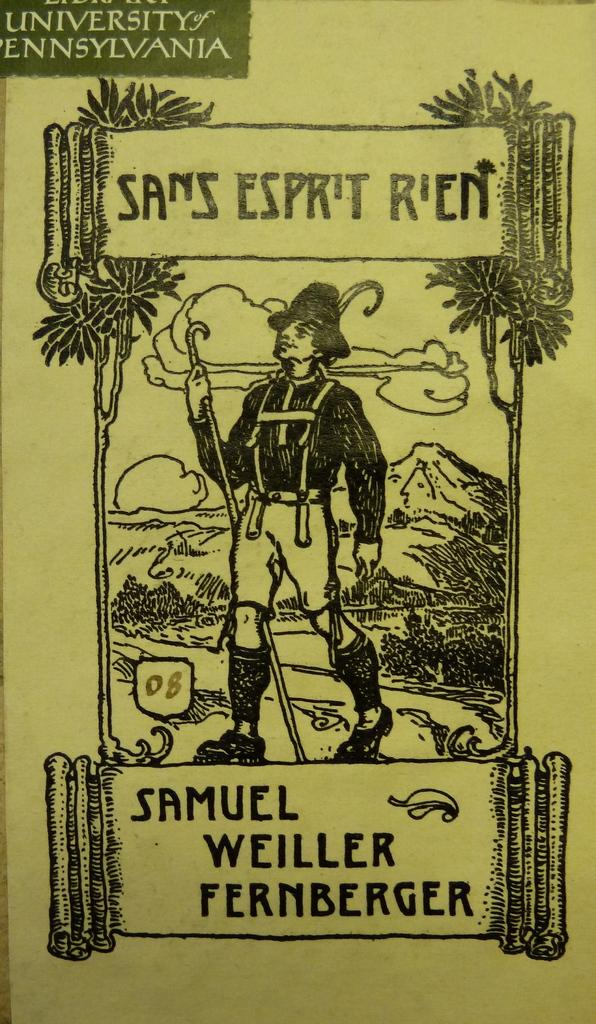Provide a one-sentence caption for the provided image. A publication from the University of Pennsylvania written by Samuel Weiller Fernberger. 